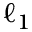<formula> <loc_0><loc_0><loc_500><loc_500>\ell _ { 1 }</formula> 